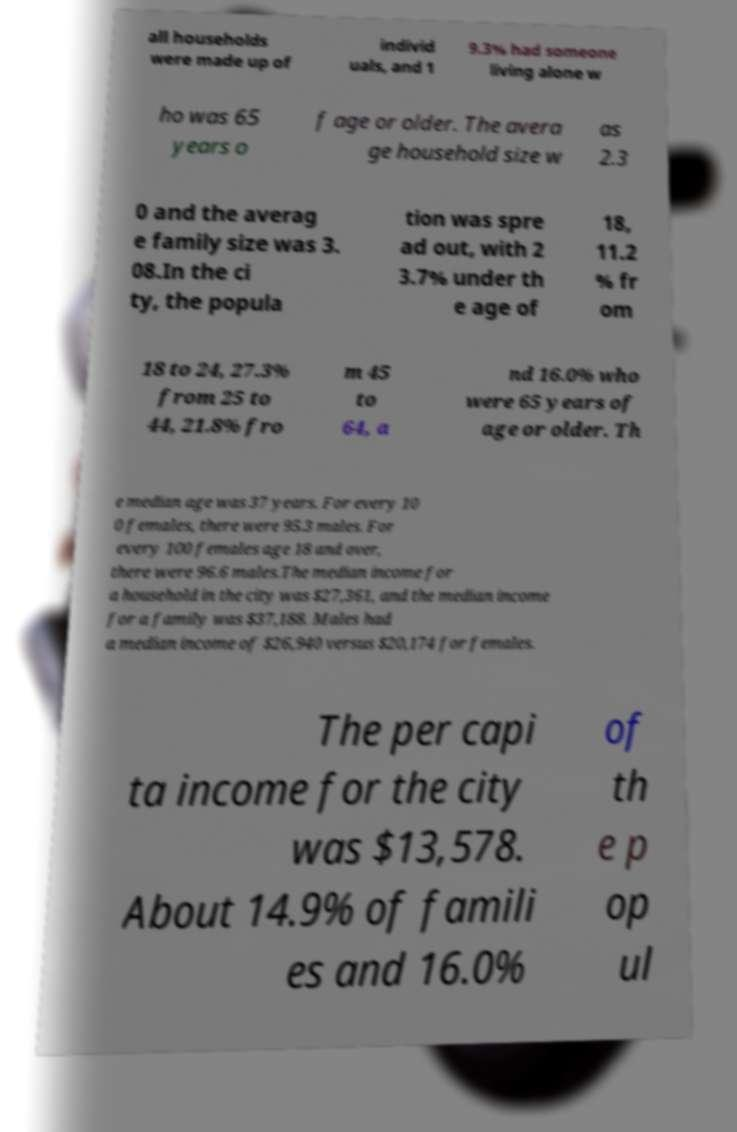Could you assist in decoding the text presented in this image and type it out clearly? all households were made up of individ uals, and 1 9.3% had someone living alone w ho was 65 years o f age or older. The avera ge household size w as 2.3 0 and the averag e family size was 3. 08.In the ci ty, the popula tion was spre ad out, with 2 3.7% under th e age of 18, 11.2 % fr om 18 to 24, 27.3% from 25 to 44, 21.8% fro m 45 to 64, a nd 16.0% who were 65 years of age or older. Th e median age was 37 years. For every 10 0 females, there were 95.3 males. For every 100 females age 18 and over, there were 96.6 males.The median income for a household in the city was $27,361, and the median income for a family was $37,188. Males had a median income of $26,940 versus $20,174 for females. The per capi ta income for the city was $13,578. About 14.9% of famili es and 16.0% of th e p op ul 